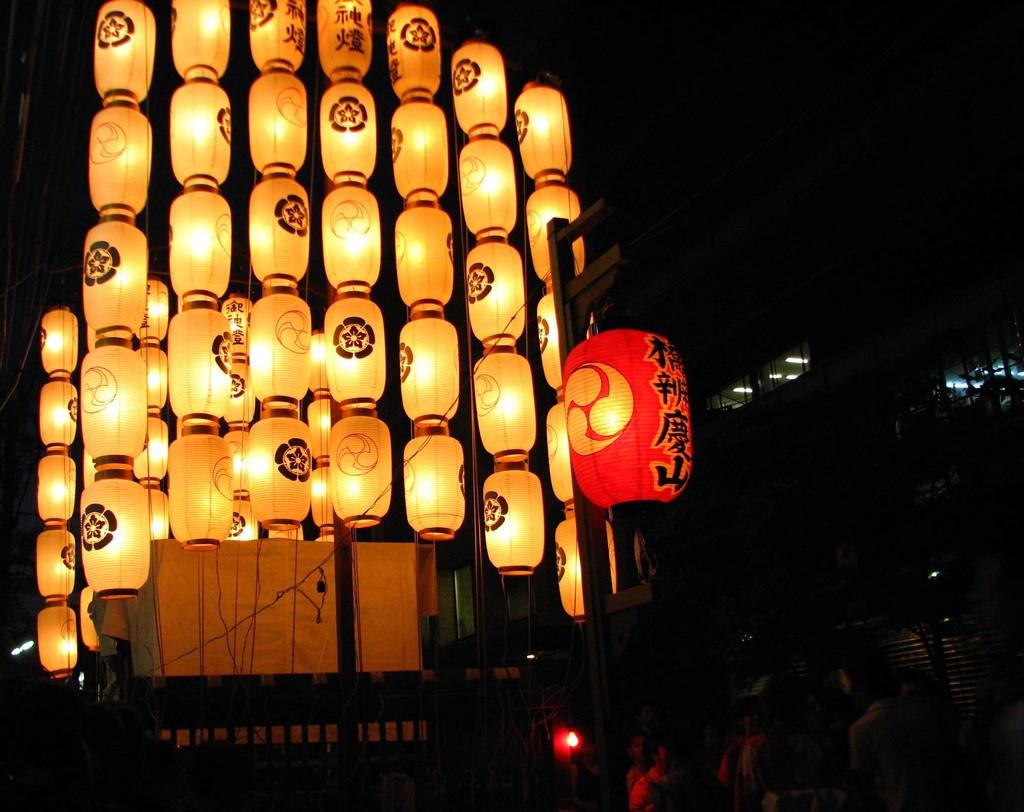What is located in the middle of the image? There are paper lanterns in the middle of the image. Can you describe the possible presence of people in the image? There may be people at the bottom of the image. What might be visible on the right side of the image? There may be a building on the right side of the image. What time of day is it in the image, given the presence of a morning dew on the faucet? There is no faucet or mention of morning dew present in the image. 